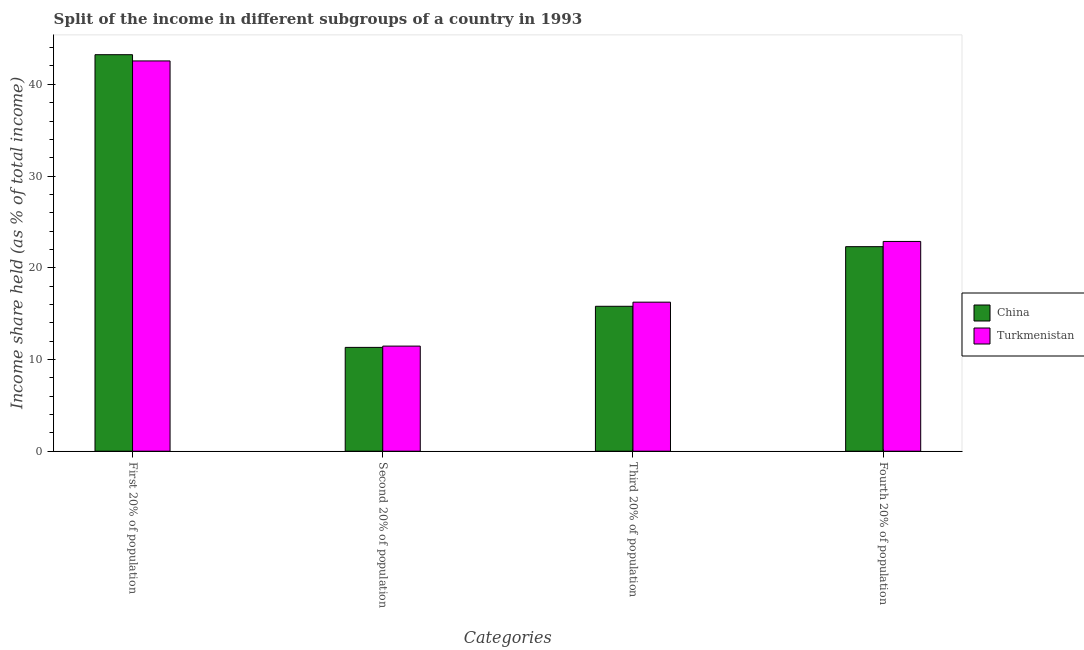How many different coloured bars are there?
Give a very brief answer. 2. How many groups of bars are there?
Keep it short and to the point. 4. Are the number of bars on each tick of the X-axis equal?
Give a very brief answer. Yes. How many bars are there on the 2nd tick from the left?
Offer a terse response. 2. How many bars are there on the 1st tick from the right?
Keep it short and to the point. 2. What is the label of the 3rd group of bars from the left?
Keep it short and to the point. Third 20% of population. What is the share of the income held by fourth 20% of the population in China?
Provide a succinct answer. 22.3. Across all countries, what is the maximum share of the income held by second 20% of the population?
Keep it short and to the point. 11.46. Across all countries, what is the minimum share of the income held by fourth 20% of the population?
Provide a short and direct response. 22.3. In which country was the share of the income held by third 20% of the population maximum?
Provide a short and direct response. Turkmenistan. What is the total share of the income held by third 20% of the population in the graph?
Make the answer very short. 32.05. What is the difference between the share of the income held by second 20% of the population in China and that in Turkmenistan?
Offer a terse response. -0.14. What is the difference between the share of the income held by third 20% of the population in China and the share of the income held by first 20% of the population in Turkmenistan?
Offer a very short reply. -26.75. What is the average share of the income held by first 20% of the population per country?
Your answer should be compact. 42.89. In how many countries, is the share of the income held by third 20% of the population greater than 4 %?
Provide a succinct answer. 2. What is the ratio of the share of the income held by first 20% of the population in China to that in Turkmenistan?
Provide a succinct answer. 1.02. Is the difference between the share of the income held by first 20% of the population in China and Turkmenistan greater than the difference between the share of the income held by third 20% of the population in China and Turkmenistan?
Offer a terse response. Yes. What is the difference between the highest and the second highest share of the income held by fourth 20% of the population?
Offer a terse response. 0.57. What is the difference between the highest and the lowest share of the income held by second 20% of the population?
Make the answer very short. 0.14. In how many countries, is the share of the income held by third 20% of the population greater than the average share of the income held by third 20% of the population taken over all countries?
Provide a succinct answer. 1. Is the sum of the share of the income held by fourth 20% of the population in Turkmenistan and China greater than the maximum share of the income held by second 20% of the population across all countries?
Your response must be concise. Yes. Is it the case that in every country, the sum of the share of the income held by third 20% of the population and share of the income held by fourth 20% of the population is greater than the sum of share of the income held by second 20% of the population and share of the income held by first 20% of the population?
Keep it short and to the point. Yes. What does the 2nd bar from the left in Second 20% of population represents?
Give a very brief answer. Turkmenistan. Are all the bars in the graph horizontal?
Provide a succinct answer. No. Are the values on the major ticks of Y-axis written in scientific E-notation?
Ensure brevity in your answer.  No. Does the graph contain any zero values?
Provide a succinct answer. No. Does the graph contain grids?
Your answer should be very brief. No. How are the legend labels stacked?
Provide a short and direct response. Vertical. What is the title of the graph?
Provide a short and direct response. Split of the income in different subgroups of a country in 1993. What is the label or title of the X-axis?
Your response must be concise. Categories. What is the label or title of the Y-axis?
Your answer should be compact. Income share held (as % of total income). What is the Income share held (as % of total income) of China in First 20% of population?
Your answer should be compact. 43.23. What is the Income share held (as % of total income) of Turkmenistan in First 20% of population?
Provide a succinct answer. 42.55. What is the Income share held (as % of total income) in China in Second 20% of population?
Your answer should be compact. 11.32. What is the Income share held (as % of total income) of Turkmenistan in Second 20% of population?
Offer a terse response. 11.46. What is the Income share held (as % of total income) of China in Third 20% of population?
Ensure brevity in your answer.  15.8. What is the Income share held (as % of total income) in Turkmenistan in Third 20% of population?
Offer a very short reply. 16.25. What is the Income share held (as % of total income) of China in Fourth 20% of population?
Offer a terse response. 22.3. What is the Income share held (as % of total income) in Turkmenistan in Fourth 20% of population?
Make the answer very short. 22.87. Across all Categories, what is the maximum Income share held (as % of total income) of China?
Your response must be concise. 43.23. Across all Categories, what is the maximum Income share held (as % of total income) of Turkmenistan?
Your answer should be very brief. 42.55. Across all Categories, what is the minimum Income share held (as % of total income) in China?
Ensure brevity in your answer.  11.32. Across all Categories, what is the minimum Income share held (as % of total income) in Turkmenistan?
Your response must be concise. 11.46. What is the total Income share held (as % of total income) of China in the graph?
Make the answer very short. 92.65. What is the total Income share held (as % of total income) of Turkmenistan in the graph?
Give a very brief answer. 93.13. What is the difference between the Income share held (as % of total income) in China in First 20% of population and that in Second 20% of population?
Give a very brief answer. 31.91. What is the difference between the Income share held (as % of total income) of Turkmenistan in First 20% of population and that in Second 20% of population?
Give a very brief answer. 31.09. What is the difference between the Income share held (as % of total income) in China in First 20% of population and that in Third 20% of population?
Provide a succinct answer. 27.43. What is the difference between the Income share held (as % of total income) of Turkmenistan in First 20% of population and that in Third 20% of population?
Your response must be concise. 26.3. What is the difference between the Income share held (as % of total income) of China in First 20% of population and that in Fourth 20% of population?
Keep it short and to the point. 20.93. What is the difference between the Income share held (as % of total income) in Turkmenistan in First 20% of population and that in Fourth 20% of population?
Provide a succinct answer. 19.68. What is the difference between the Income share held (as % of total income) of China in Second 20% of population and that in Third 20% of population?
Make the answer very short. -4.48. What is the difference between the Income share held (as % of total income) in Turkmenistan in Second 20% of population and that in Third 20% of population?
Your response must be concise. -4.79. What is the difference between the Income share held (as % of total income) of China in Second 20% of population and that in Fourth 20% of population?
Give a very brief answer. -10.98. What is the difference between the Income share held (as % of total income) in Turkmenistan in Second 20% of population and that in Fourth 20% of population?
Your answer should be very brief. -11.41. What is the difference between the Income share held (as % of total income) in China in Third 20% of population and that in Fourth 20% of population?
Keep it short and to the point. -6.5. What is the difference between the Income share held (as % of total income) in Turkmenistan in Third 20% of population and that in Fourth 20% of population?
Give a very brief answer. -6.62. What is the difference between the Income share held (as % of total income) of China in First 20% of population and the Income share held (as % of total income) of Turkmenistan in Second 20% of population?
Offer a terse response. 31.77. What is the difference between the Income share held (as % of total income) in China in First 20% of population and the Income share held (as % of total income) in Turkmenistan in Third 20% of population?
Make the answer very short. 26.98. What is the difference between the Income share held (as % of total income) in China in First 20% of population and the Income share held (as % of total income) in Turkmenistan in Fourth 20% of population?
Ensure brevity in your answer.  20.36. What is the difference between the Income share held (as % of total income) of China in Second 20% of population and the Income share held (as % of total income) of Turkmenistan in Third 20% of population?
Ensure brevity in your answer.  -4.93. What is the difference between the Income share held (as % of total income) of China in Second 20% of population and the Income share held (as % of total income) of Turkmenistan in Fourth 20% of population?
Give a very brief answer. -11.55. What is the difference between the Income share held (as % of total income) in China in Third 20% of population and the Income share held (as % of total income) in Turkmenistan in Fourth 20% of population?
Make the answer very short. -7.07. What is the average Income share held (as % of total income) of China per Categories?
Offer a very short reply. 23.16. What is the average Income share held (as % of total income) of Turkmenistan per Categories?
Keep it short and to the point. 23.28. What is the difference between the Income share held (as % of total income) in China and Income share held (as % of total income) in Turkmenistan in First 20% of population?
Your response must be concise. 0.68. What is the difference between the Income share held (as % of total income) in China and Income share held (as % of total income) in Turkmenistan in Second 20% of population?
Provide a short and direct response. -0.14. What is the difference between the Income share held (as % of total income) in China and Income share held (as % of total income) in Turkmenistan in Third 20% of population?
Keep it short and to the point. -0.45. What is the difference between the Income share held (as % of total income) in China and Income share held (as % of total income) in Turkmenistan in Fourth 20% of population?
Your answer should be very brief. -0.57. What is the ratio of the Income share held (as % of total income) of China in First 20% of population to that in Second 20% of population?
Give a very brief answer. 3.82. What is the ratio of the Income share held (as % of total income) of Turkmenistan in First 20% of population to that in Second 20% of population?
Make the answer very short. 3.71. What is the ratio of the Income share held (as % of total income) of China in First 20% of population to that in Third 20% of population?
Your answer should be compact. 2.74. What is the ratio of the Income share held (as % of total income) of Turkmenistan in First 20% of population to that in Third 20% of population?
Keep it short and to the point. 2.62. What is the ratio of the Income share held (as % of total income) in China in First 20% of population to that in Fourth 20% of population?
Give a very brief answer. 1.94. What is the ratio of the Income share held (as % of total income) of Turkmenistan in First 20% of population to that in Fourth 20% of population?
Offer a very short reply. 1.86. What is the ratio of the Income share held (as % of total income) in China in Second 20% of population to that in Third 20% of population?
Ensure brevity in your answer.  0.72. What is the ratio of the Income share held (as % of total income) of Turkmenistan in Second 20% of population to that in Third 20% of population?
Make the answer very short. 0.71. What is the ratio of the Income share held (as % of total income) in China in Second 20% of population to that in Fourth 20% of population?
Ensure brevity in your answer.  0.51. What is the ratio of the Income share held (as % of total income) in Turkmenistan in Second 20% of population to that in Fourth 20% of population?
Provide a succinct answer. 0.5. What is the ratio of the Income share held (as % of total income) of China in Third 20% of population to that in Fourth 20% of population?
Offer a terse response. 0.71. What is the ratio of the Income share held (as % of total income) in Turkmenistan in Third 20% of population to that in Fourth 20% of population?
Provide a succinct answer. 0.71. What is the difference between the highest and the second highest Income share held (as % of total income) of China?
Offer a terse response. 20.93. What is the difference between the highest and the second highest Income share held (as % of total income) of Turkmenistan?
Make the answer very short. 19.68. What is the difference between the highest and the lowest Income share held (as % of total income) in China?
Give a very brief answer. 31.91. What is the difference between the highest and the lowest Income share held (as % of total income) in Turkmenistan?
Ensure brevity in your answer.  31.09. 